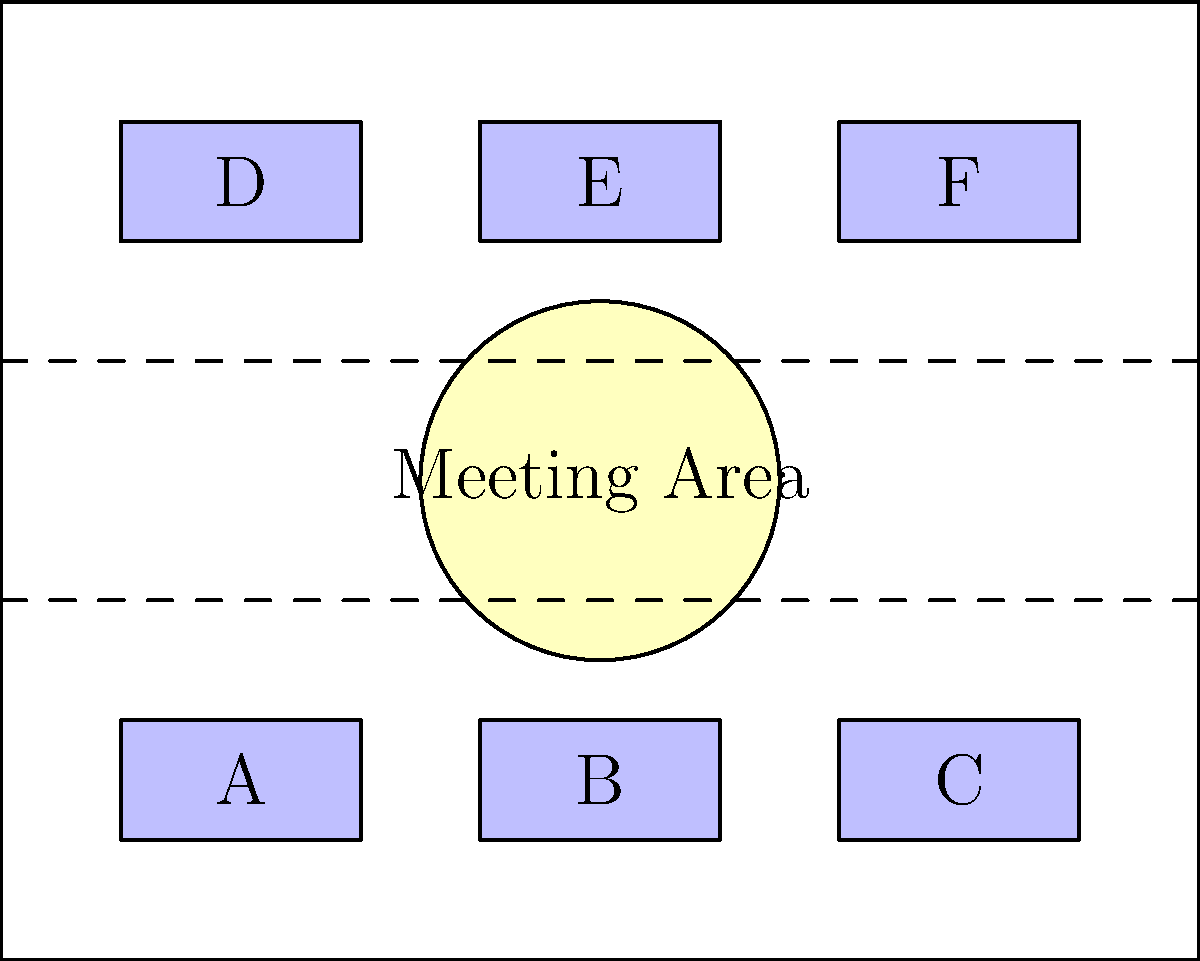In the startup office layout shown above, you need to optimize the space for better collaboration while keeping an eye on your father's desk. If your father sits at desk A, which desk should you choose to maximize your ability to monitor his well-being while maintaining proximity to the meeting area for quick team collaborations? To solve this problem, we need to consider several factors:

1. Proximity to desk A (father's desk):
   - Desks B and D are closest to A.

2. Distance to the meeting area:
   - Desks B, C, E, and F are closer to the meeting area than D.

3. Line of sight to desk A:
   - From desk D, there's a clear line of sight to A.
   - From desk B, the view might be partially obstructed by other team members.

4. Balancing collaboration and monitoring:
   - Desk B offers a good balance between proximity to A and the meeting area.
   - Desk D provides the best view of A but is furthest from the meeting area.

5. Considering the persona's need for innovation and team collaboration:
   - Being close to the meeting area is important for quick team interactions.

6. Factoring in the need to monitor father's well-being:
   - A position with a clear view of desk A is crucial.

Weighing these factors, desk B emerges as the optimal choice:
- It's adjacent to desk A, allowing for easy monitoring.
- It's close to the meeting area, facilitating quick collaborations.
- While the line of sight might not be perfect, the proximity compensates for this.
- It balances the needs of being an innovative entrepreneur with keeping an eye on her father.
Answer: Desk B 